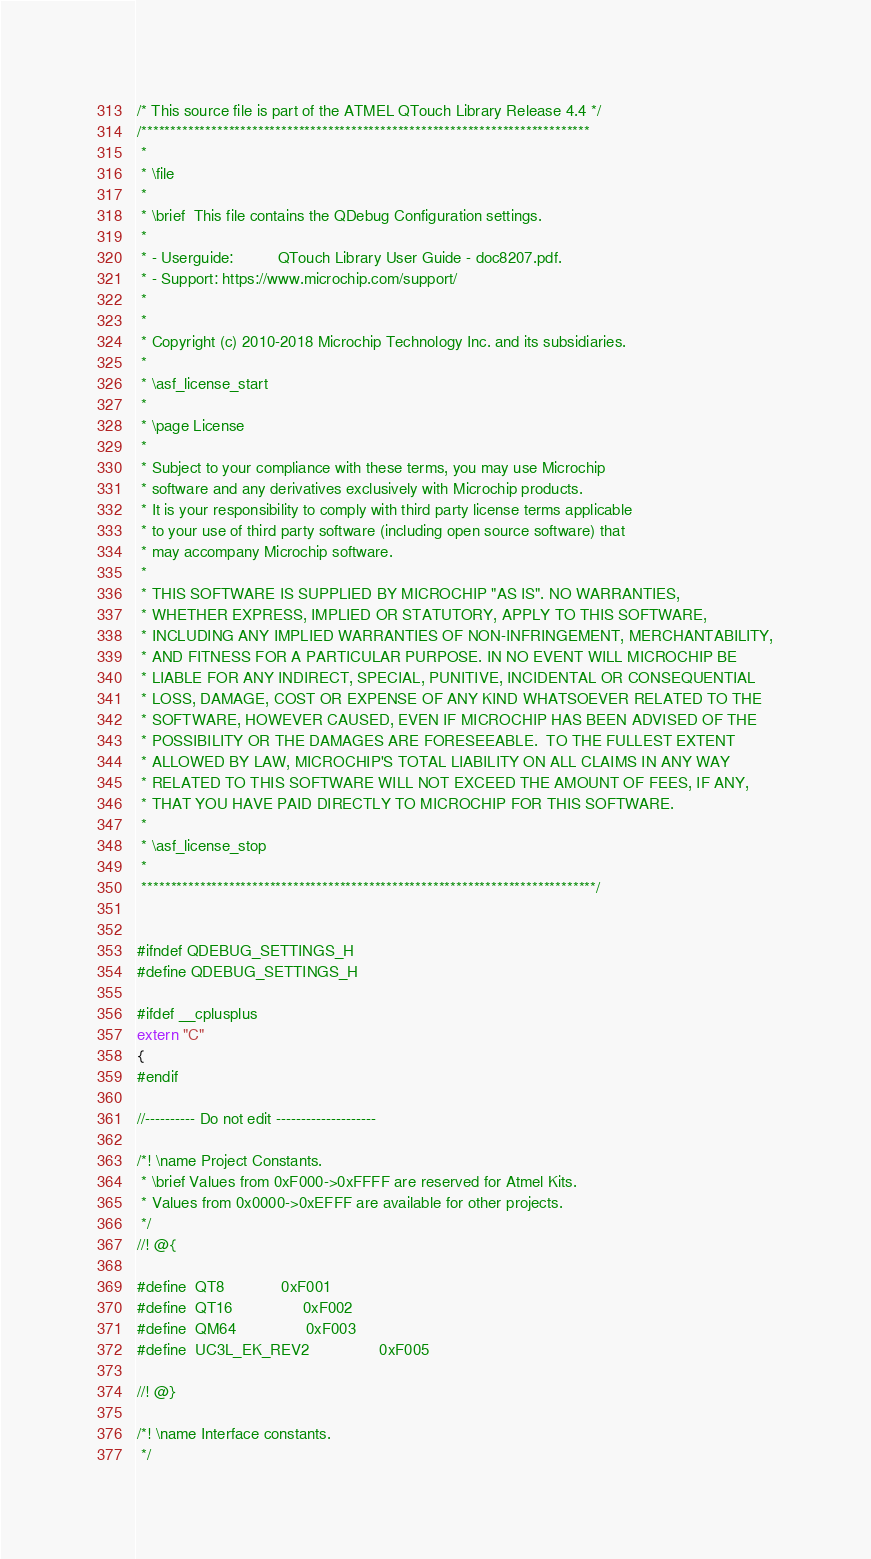Convert code to text. <code><loc_0><loc_0><loc_500><loc_500><_C_>/* This source file is part of the ATMEL QTouch Library Release 4.4 */
/*****************************************************************************
 *
 * \file
 *
 * \brief  This file contains the QDebug Configuration settings.
 *
 * - Userguide:          QTouch Library User Guide - doc8207.pdf.
 * - Support: https://www.microchip.com/support/
 *
 *
 * Copyright (c) 2010-2018 Microchip Technology Inc. and its subsidiaries.
 *
 * \asf_license_start
 *
 * \page License
 *
 * Subject to your compliance with these terms, you may use Microchip
 * software and any derivatives exclusively with Microchip products.
 * It is your responsibility to comply with third party license terms applicable
 * to your use of third party software (including open source software) that
 * may accompany Microchip software.
 *
 * THIS SOFTWARE IS SUPPLIED BY MICROCHIP "AS IS". NO WARRANTIES,
 * WHETHER EXPRESS, IMPLIED OR STATUTORY, APPLY TO THIS SOFTWARE,
 * INCLUDING ANY IMPLIED WARRANTIES OF NON-INFRINGEMENT, MERCHANTABILITY,
 * AND FITNESS FOR A PARTICULAR PURPOSE. IN NO EVENT WILL MICROCHIP BE
 * LIABLE FOR ANY INDIRECT, SPECIAL, PUNITIVE, INCIDENTAL OR CONSEQUENTIAL
 * LOSS, DAMAGE, COST OR EXPENSE OF ANY KIND WHATSOEVER RELATED TO THE
 * SOFTWARE, HOWEVER CAUSED, EVEN IF MICROCHIP HAS BEEN ADVISED OF THE
 * POSSIBILITY OR THE DAMAGES ARE FORESEEABLE.  TO THE FULLEST EXTENT
 * ALLOWED BY LAW, MICROCHIP'S TOTAL LIABILITY ON ALL CLAIMS IN ANY WAY
 * RELATED TO THIS SOFTWARE WILL NOT EXCEED THE AMOUNT OF FEES, IF ANY,
 * THAT YOU HAVE PAID DIRECTLY TO MICROCHIP FOR THIS SOFTWARE.
 *
 * \asf_license_stop
 *
 ******************************************************************************/


#ifndef QDEBUG_SETTINGS_H
#define QDEBUG_SETTINGS_H

#ifdef __cplusplus
extern "C"
{
#endif

//---------- Do not edit --------------------

/*! \name Project Constants.
 * \brief Values from 0xF000->0xFFFF are reserved for Atmel Kits.
 * Values from 0x0000->0xEFFF are available for other projects.
 */
//! @{

#define 	QT8				0xF001
#define 	QT16				0xF002
#define 	QM64				0xF003
#define 	UC3L_EK_REV2		        0xF005

//! @}

/*! \name Interface constants.
 */</code> 